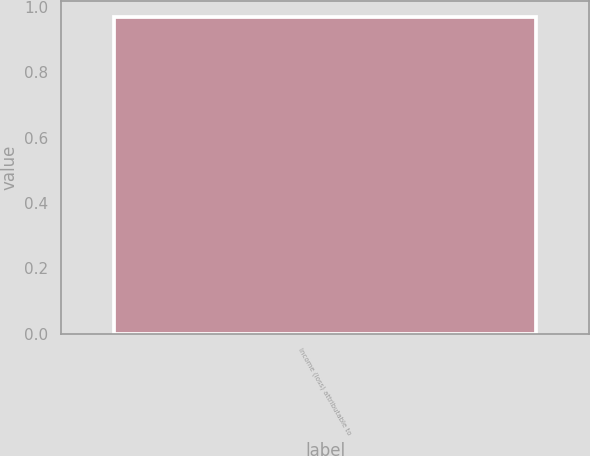Convert chart to OTSL. <chart><loc_0><loc_0><loc_500><loc_500><bar_chart><fcel>Income (loss) attributable to<nl><fcel>0.97<nl></chart> 